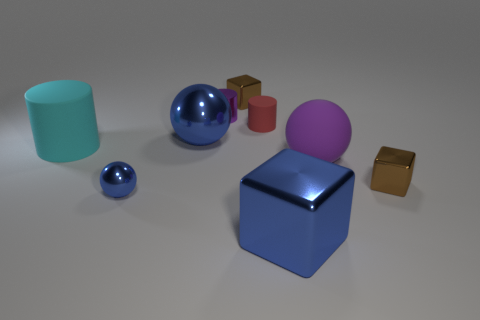What number of cyan objects are either shiny things or large objects?
Offer a terse response. 1. There is a large matte cylinder; are there any large cyan objects in front of it?
Ensure brevity in your answer.  No. How big is the purple ball?
Provide a succinct answer. Large. What is the size of the other rubber thing that is the same shape as the red thing?
Give a very brief answer. Large. There is a purple object in front of the tiny purple cylinder; what number of tiny purple things are in front of it?
Offer a terse response. 0. Is the tiny brown object behind the large matte cylinder made of the same material as the small thing that is on the right side of the large purple rubber thing?
Give a very brief answer. Yes. How many small purple objects have the same shape as the big purple rubber object?
Offer a very short reply. 0. How many tiny objects are the same color as the large metal sphere?
Provide a short and direct response. 1. Do the small brown thing in front of the large blue ball and the big rubber object that is left of the tiny metallic ball have the same shape?
Give a very brief answer. No. There is a rubber cylinder that is to the left of the tiny brown metal object that is on the left side of the large block; how many blue blocks are in front of it?
Give a very brief answer. 1. 